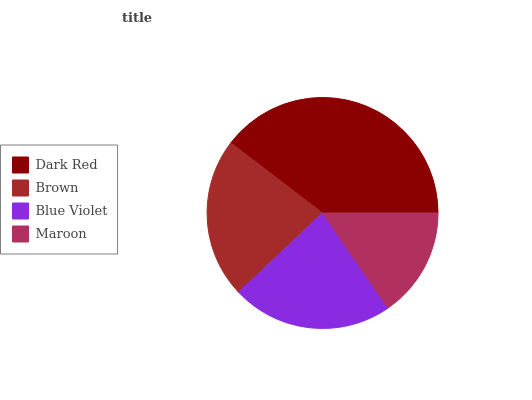Is Maroon the minimum?
Answer yes or no. Yes. Is Dark Red the maximum?
Answer yes or no. Yes. Is Brown the minimum?
Answer yes or no. No. Is Brown the maximum?
Answer yes or no. No. Is Dark Red greater than Brown?
Answer yes or no. Yes. Is Brown less than Dark Red?
Answer yes or no. Yes. Is Brown greater than Dark Red?
Answer yes or no. No. Is Dark Red less than Brown?
Answer yes or no. No. Is Blue Violet the high median?
Answer yes or no. Yes. Is Brown the low median?
Answer yes or no. Yes. Is Maroon the high median?
Answer yes or no. No. Is Blue Violet the low median?
Answer yes or no. No. 